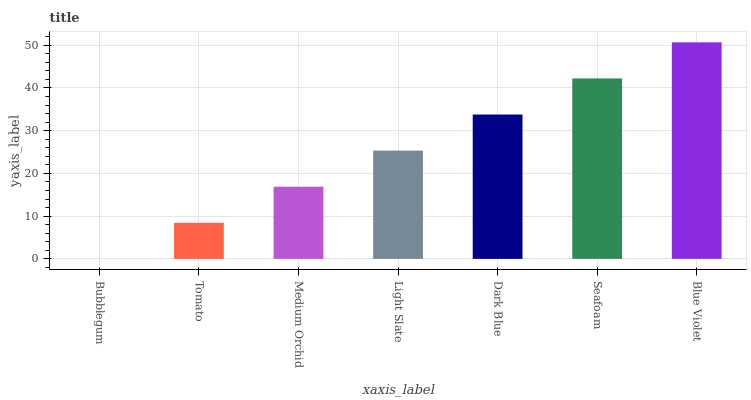Is Bubblegum the minimum?
Answer yes or no. Yes. Is Blue Violet the maximum?
Answer yes or no. Yes. Is Tomato the minimum?
Answer yes or no. No. Is Tomato the maximum?
Answer yes or no. No. Is Tomato greater than Bubblegum?
Answer yes or no. Yes. Is Bubblegum less than Tomato?
Answer yes or no. Yes. Is Bubblegum greater than Tomato?
Answer yes or no. No. Is Tomato less than Bubblegum?
Answer yes or no. No. Is Light Slate the high median?
Answer yes or no. Yes. Is Light Slate the low median?
Answer yes or no. Yes. Is Blue Violet the high median?
Answer yes or no. No. Is Blue Violet the low median?
Answer yes or no. No. 